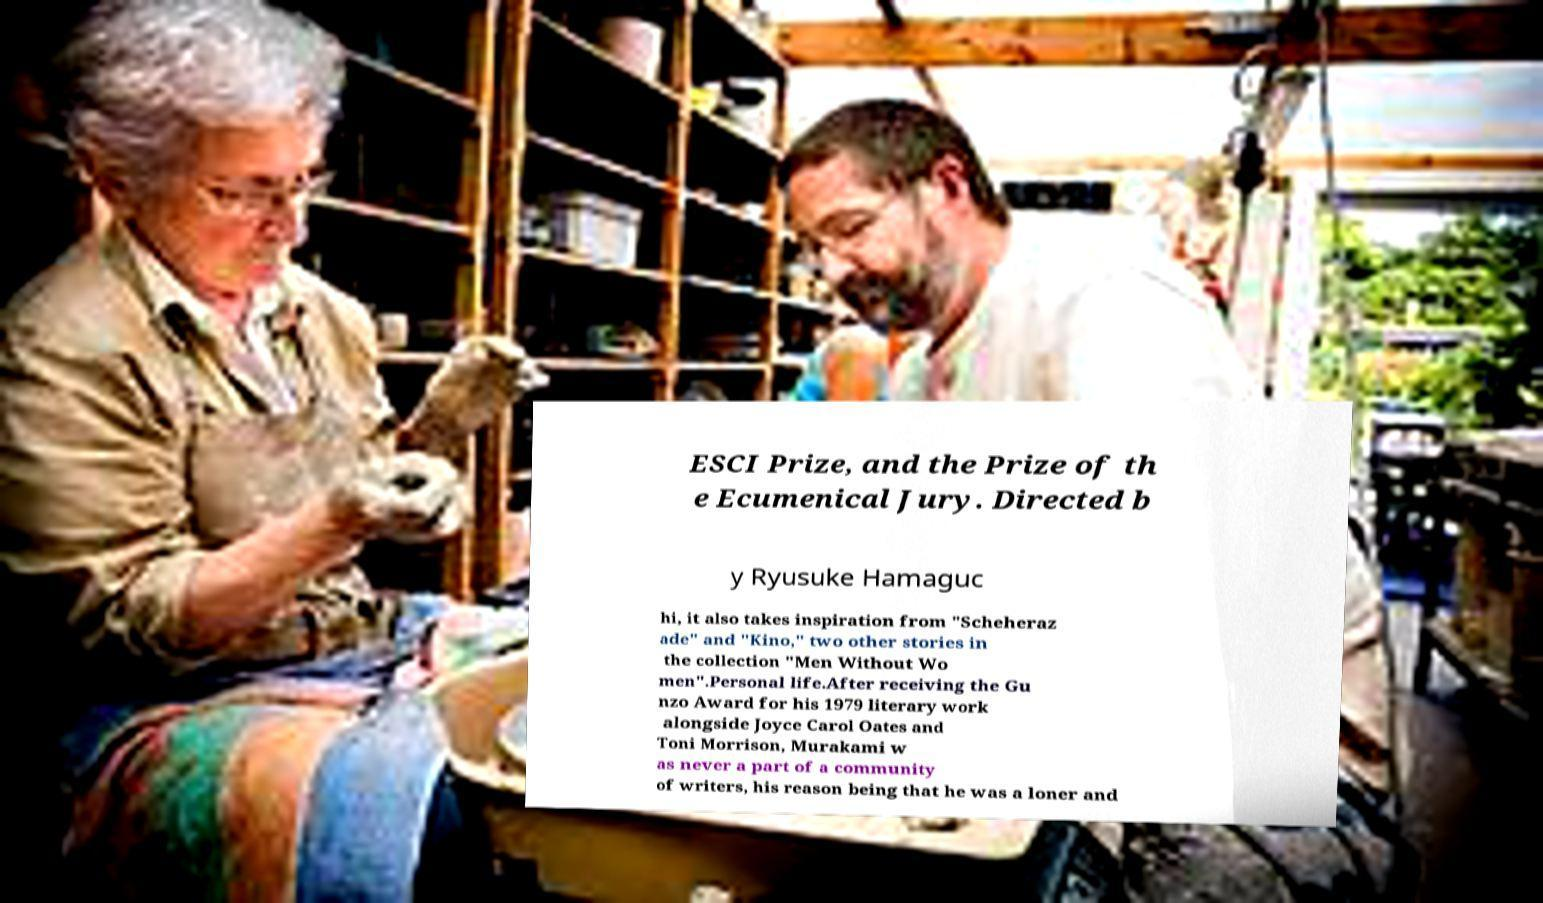For documentation purposes, I need the text within this image transcribed. Could you provide that? ESCI Prize, and the Prize of th e Ecumenical Jury. Directed b y Ryusuke Hamaguc hi, it also takes inspiration from "Scheheraz ade" and "Kino," two other stories in the collection "Men Without Wo men".Personal life.After receiving the Gu nzo Award for his 1979 literary work alongside Joyce Carol Oates and Toni Morrison, Murakami w as never a part of a community of writers, his reason being that he was a loner and 